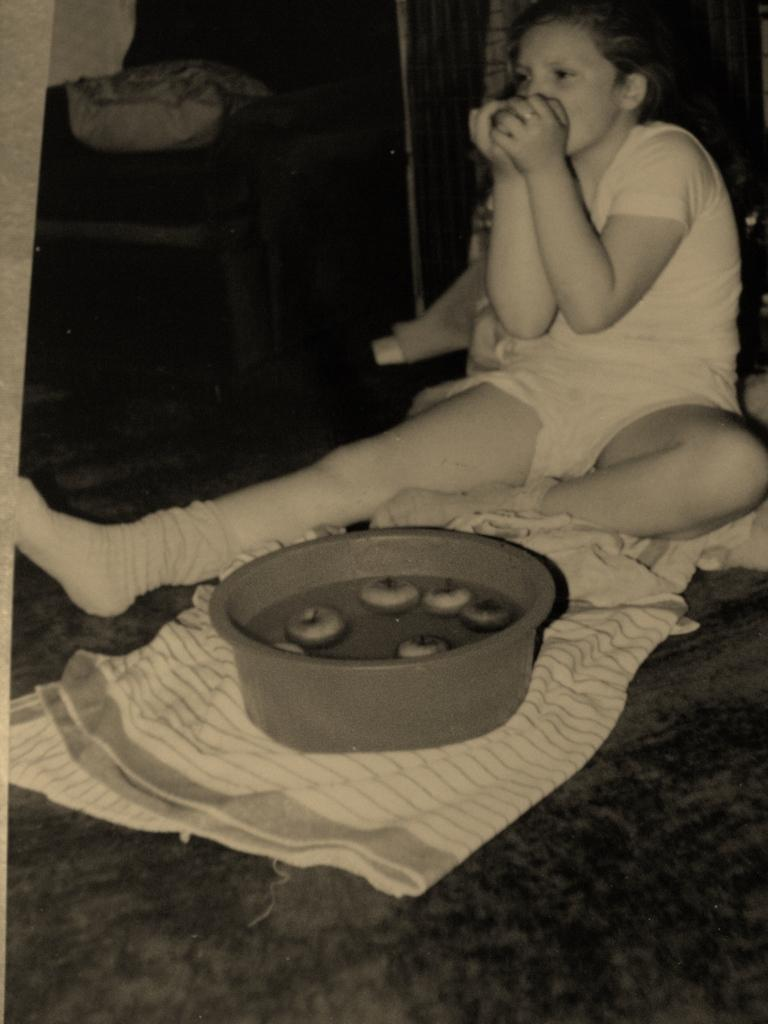What is the lady doing in the image? The lady is sitting in the image. What is the lady holding in the image? The lady is holding an object. What type of food item can be seen in the image? There is a food item in a wooden object. How is the wooden object placed in the image? The wooden object is placed on a cloth. What type of thrill can be seen in the image? There is no thrill present in the image; it features a lady sitting and holding an object. How many bubbles are visible in the image? There are no bubbles present in the image. 